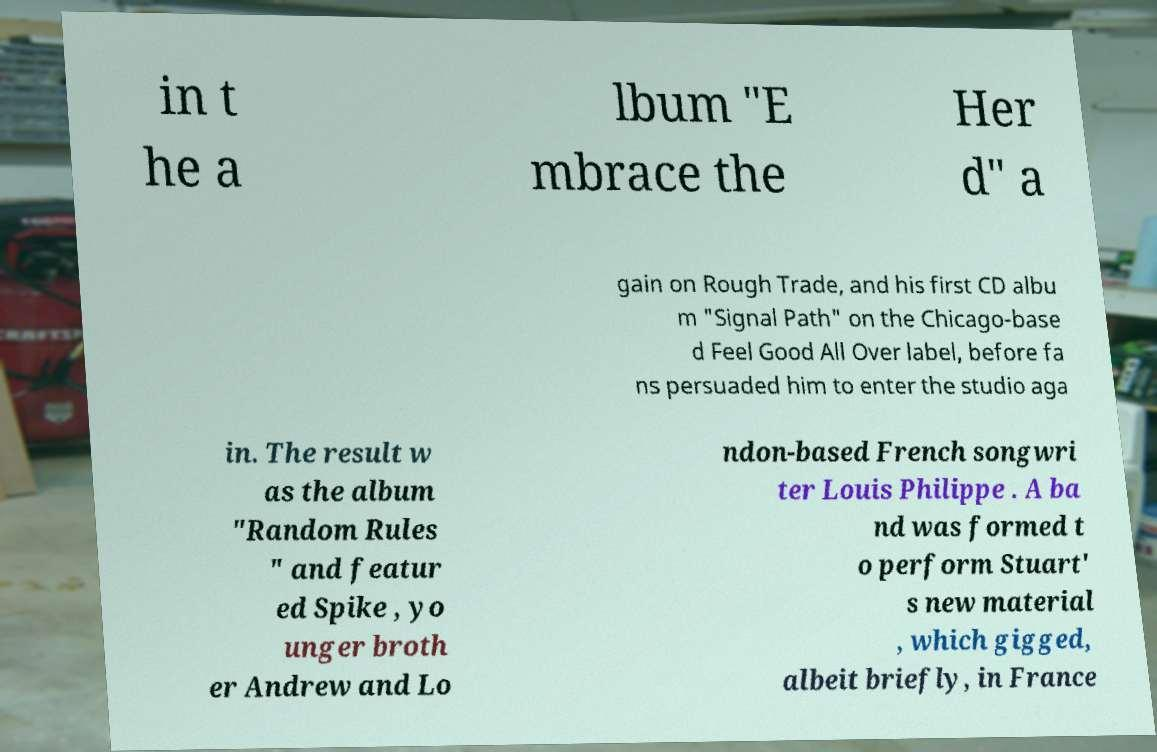Could you assist in decoding the text presented in this image and type it out clearly? in t he a lbum "E mbrace the Her d" a gain on Rough Trade, and his first CD albu m "Signal Path" on the Chicago-base d Feel Good All Over label, before fa ns persuaded him to enter the studio aga in. The result w as the album "Random Rules " and featur ed Spike , yo unger broth er Andrew and Lo ndon-based French songwri ter Louis Philippe . A ba nd was formed t o perform Stuart' s new material , which gigged, albeit briefly, in France 